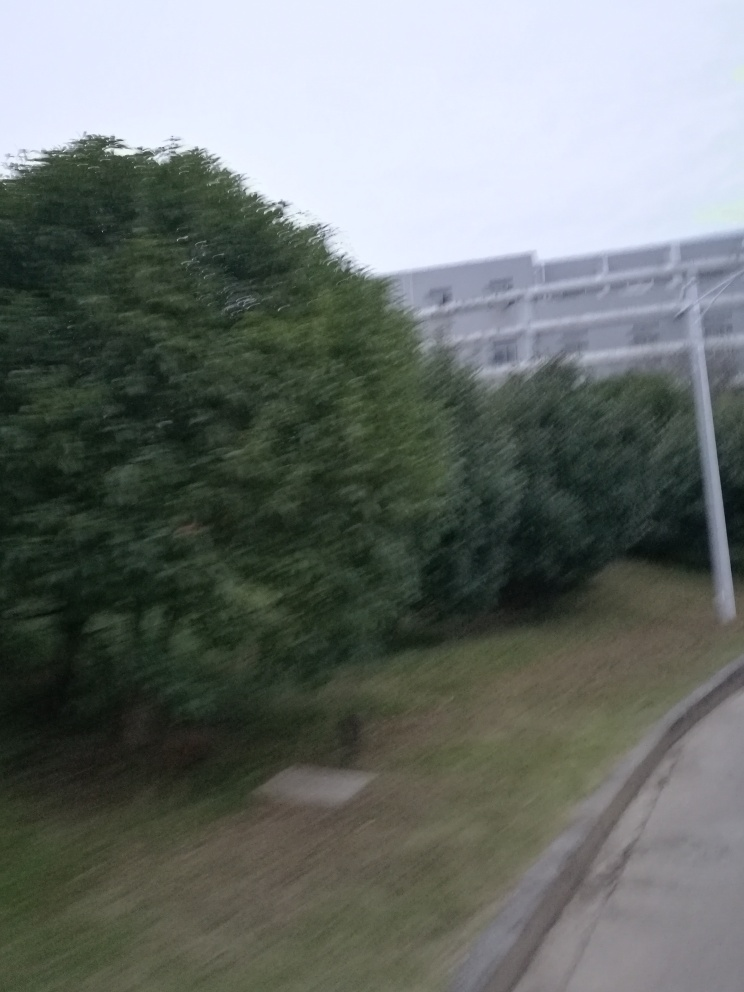Can you describe the main elements in this image and speculate on what is happening? The image appears to be taken in a hurried manner from a moving vehicle, given the motion blur. The main elements include a lush green tree on the left and a building with white and grey tones in the background. It seems like a typical urban scene, possibly captured during the early evening or on a cloudy day, considering the lighting. 